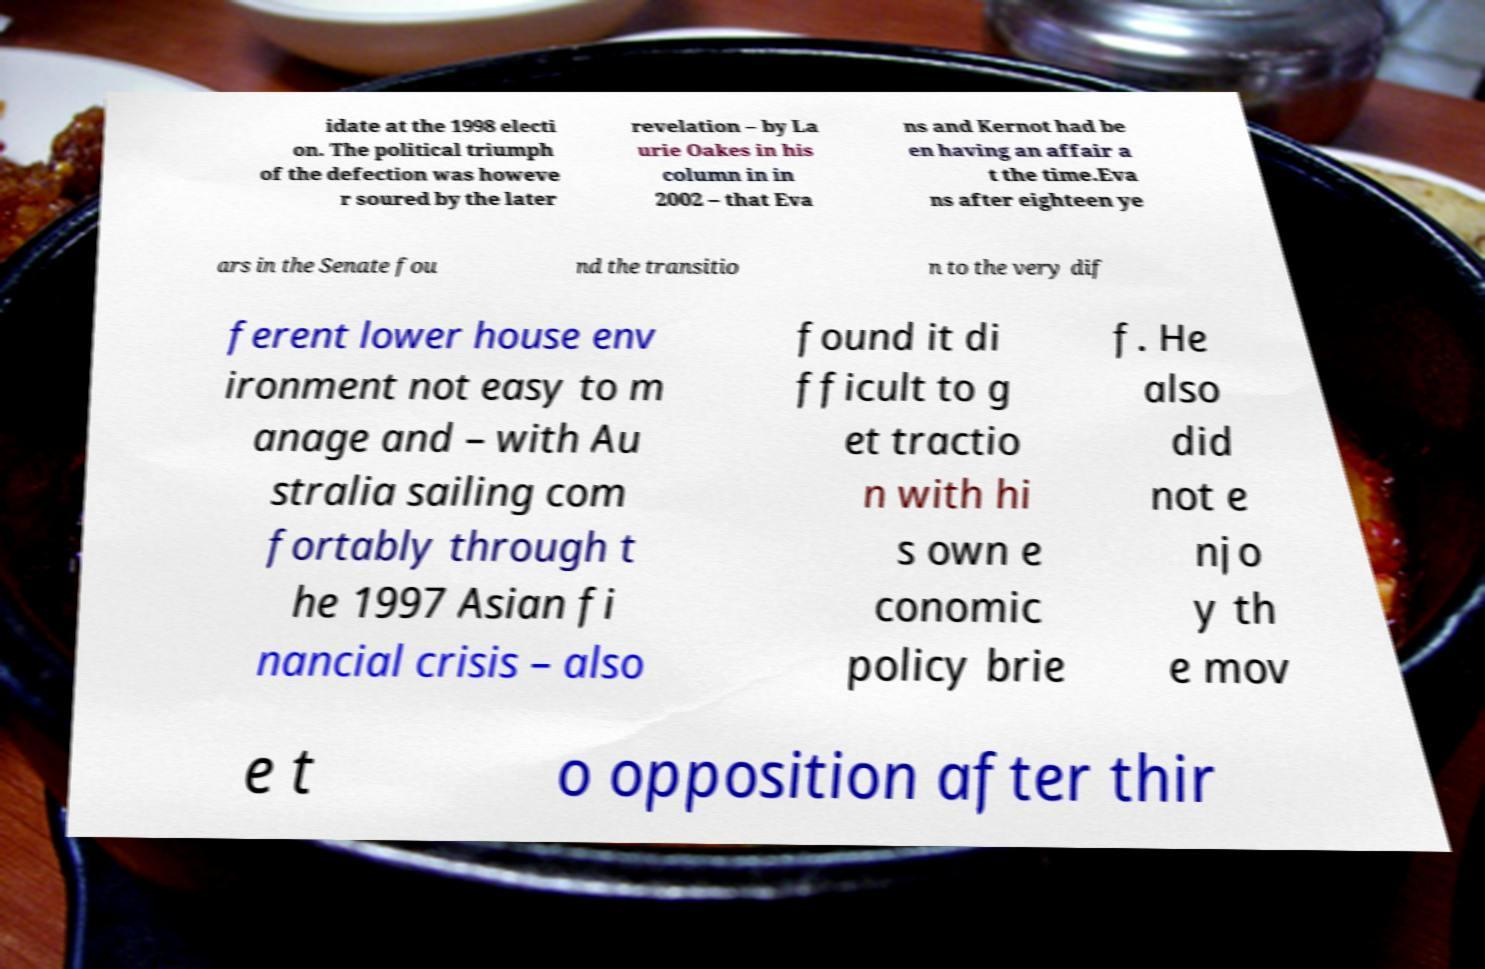Please read and relay the text visible in this image. What does it say? idate at the 1998 electi on. The political triumph of the defection was howeve r soured by the later revelation – by La urie Oakes in his column in in 2002 – that Eva ns and Kernot had be en having an affair a t the time.Eva ns after eighteen ye ars in the Senate fou nd the transitio n to the very dif ferent lower house env ironment not easy to m anage and – with Au stralia sailing com fortably through t he 1997 Asian fi nancial crisis – also found it di fficult to g et tractio n with hi s own e conomic policy brie f. He also did not e njo y th e mov e t o opposition after thir 